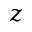Convert formula to latex. <formula><loc_0><loc_0><loc_500><loc_500>z</formula> 